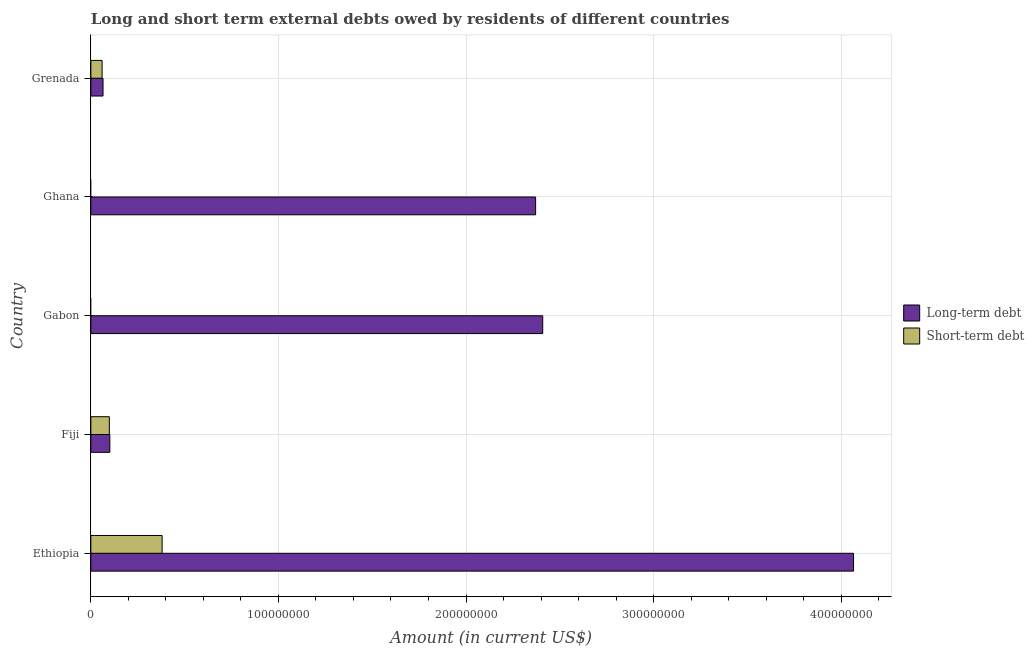How many bars are there on the 2nd tick from the top?
Your answer should be very brief. 1. How many bars are there on the 4th tick from the bottom?
Make the answer very short. 1. What is the label of the 4th group of bars from the top?
Provide a succinct answer. Fiji. In how many cases, is the number of bars for a given country not equal to the number of legend labels?
Your answer should be compact. 2. What is the long-term debts owed by residents in Grenada?
Make the answer very short. 6.49e+06. Across all countries, what is the maximum short-term debts owed by residents?
Make the answer very short. 3.80e+07. In which country was the long-term debts owed by residents maximum?
Your answer should be compact. Ethiopia. What is the total short-term debts owed by residents in the graph?
Your answer should be very brief. 5.39e+07. What is the difference between the long-term debts owed by residents in Fiji and that in Grenada?
Provide a succinct answer. 3.63e+06. What is the difference between the short-term debts owed by residents in Grenada and the long-term debts owed by residents in Ghana?
Provide a short and direct response. -2.31e+08. What is the average long-term debts owed by residents per country?
Make the answer very short. 1.80e+08. What is the difference between the short-term debts owed by residents and long-term debts owed by residents in Fiji?
Offer a terse response. -2.59e+05. What is the ratio of the long-term debts owed by residents in Fiji to that in Gabon?
Make the answer very short. 0.04. Is the long-term debts owed by residents in Ethiopia less than that in Ghana?
Give a very brief answer. No. Is the difference between the long-term debts owed by residents in Ethiopia and Grenada greater than the difference between the short-term debts owed by residents in Ethiopia and Grenada?
Provide a succinct answer. Yes. What is the difference between the highest and the second highest long-term debts owed by residents?
Your response must be concise. 1.66e+08. What is the difference between the highest and the lowest short-term debts owed by residents?
Offer a terse response. 3.80e+07. Is the sum of the short-term debts owed by residents in Ethiopia and Grenada greater than the maximum long-term debts owed by residents across all countries?
Keep it short and to the point. No. How many bars are there?
Give a very brief answer. 8. How many countries are there in the graph?
Your answer should be very brief. 5. Are the values on the major ticks of X-axis written in scientific E-notation?
Give a very brief answer. No. Does the graph contain grids?
Offer a terse response. Yes. Where does the legend appear in the graph?
Give a very brief answer. Center right. How are the legend labels stacked?
Keep it short and to the point. Vertical. What is the title of the graph?
Give a very brief answer. Long and short term external debts owed by residents of different countries. What is the label or title of the X-axis?
Offer a very short reply. Amount (in current US$). What is the label or title of the Y-axis?
Provide a short and direct response. Country. What is the Amount (in current US$) of Long-term debt in Ethiopia?
Your response must be concise. 4.07e+08. What is the Amount (in current US$) of Short-term debt in Ethiopia?
Give a very brief answer. 3.80e+07. What is the Amount (in current US$) of Long-term debt in Fiji?
Offer a terse response. 1.01e+07. What is the Amount (in current US$) of Short-term debt in Fiji?
Make the answer very short. 9.86e+06. What is the Amount (in current US$) of Long-term debt in Gabon?
Make the answer very short. 2.41e+08. What is the Amount (in current US$) of Short-term debt in Gabon?
Your answer should be compact. 0. What is the Amount (in current US$) in Long-term debt in Ghana?
Your response must be concise. 2.37e+08. What is the Amount (in current US$) of Long-term debt in Grenada?
Give a very brief answer. 6.49e+06. What is the Amount (in current US$) in Short-term debt in Grenada?
Offer a very short reply. 6.00e+06. Across all countries, what is the maximum Amount (in current US$) in Long-term debt?
Your answer should be compact. 4.07e+08. Across all countries, what is the maximum Amount (in current US$) in Short-term debt?
Provide a succinct answer. 3.80e+07. Across all countries, what is the minimum Amount (in current US$) of Long-term debt?
Your answer should be very brief. 6.49e+06. Across all countries, what is the minimum Amount (in current US$) in Short-term debt?
Your answer should be compact. 0. What is the total Amount (in current US$) in Long-term debt in the graph?
Your answer should be very brief. 9.01e+08. What is the total Amount (in current US$) of Short-term debt in the graph?
Offer a terse response. 5.39e+07. What is the difference between the Amount (in current US$) in Long-term debt in Ethiopia and that in Fiji?
Provide a succinct answer. 3.96e+08. What is the difference between the Amount (in current US$) in Short-term debt in Ethiopia and that in Fiji?
Give a very brief answer. 2.81e+07. What is the difference between the Amount (in current US$) of Long-term debt in Ethiopia and that in Gabon?
Your answer should be compact. 1.66e+08. What is the difference between the Amount (in current US$) in Long-term debt in Ethiopia and that in Ghana?
Give a very brief answer. 1.69e+08. What is the difference between the Amount (in current US$) of Long-term debt in Ethiopia and that in Grenada?
Ensure brevity in your answer.  4.00e+08. What is the difference between the Amount (in current US$) of Short-term debt in Ethiopia and that in Grenada?
Your answer should be compact. 3.20e+07. What is the difference between the Amount (in current US$) in Long-term debt in Fiji and that in Gabon?
Offer a terse response. -2.31e+08. What is the difference between the Amount (in current US$) of Long-term debt in Fiji and that in Ghana?
Offer a very short reply. -2.27e+08. What is the difference between the Amount (in current US$) of Long-term debt in Fiji and that in Grenada?
Keep it short and to the point. 3.63e+06. What is the difference between the Amount (in current US$) in Short-term debt in Fiji and that in Grenada?
Ensure brevity in your answer.  3.86e+06. What is the difference between the Amount (in current US$) in Long-term debt in Gabon and that in Ghana?
Your answer should be compact. 3.78e+06. What is the difference between the Amount (in current US$) of Long-term debt in Gabon and that in Grenada?
Provide a short and direct response. 2.34e+08. What is the difference between the Amount (in current US$) of Long-term debt in Ghana and that in Grenada?
Provide a short and direct response. 2.31e+08. What is the difference between the Amount (in current US$) of Long-term debt in Ethiopia and the Amount (in current US$) of Short-term debt in Fiji?
Provide a short and direct response. 3.97e+08. What is the difference between the Amount (in current US$) of Long-term debt in Ethiopia and the Amount (in current US$) of Short-term debt in Grenada?
Offer a terse response. 4.01e+08. What is the difference between the Amount (in current US$) of Long-term debt in Fiji and the Amount (in current US$) of Short-term debt in Grenada?
Your response must be concise. 4.12e+06. What is the difference between the Amount (in current US$) of Long-term debt in Gabon and the Amount (in current US$) of Short-term debt in Grenada?
Offer a very short reply. 2.35e+08. What is the difference between the Amount (in current US$) in Long-term debt in Ghana and the Amount (in current US$) in Short-term debt in Grenada?
Ensure brevity in your answer.  2.31e+08. What is the average Amount (in current US$) in Long-term debt per country?
Offer a very short reply. 1.80e+08. What is the average Amount (in current US$) in Short-term debt per country?
Offer a terse response. 1.08e+07. What is the difference between the Amount (in current US$) in Long-term debt and Amount (in current US$) in Short-term debt in Ethiopia?
Make the answer very short. 3.69e+08. What is the difference between the Amount (in current US$) in Long-term debt and Amount (in current US$) in Short-term debt in Fiji?
Offer a very short reply. 2.59e+05. What is the difference between the Amount (in current US$) of Long-term debt and Amount (in current US$) of Short-term debt in Grenada?
Provide a succinct answer. 4.93e+05. What is the ratio of the Amount (in current US$) in Long-term debt in Ethiopia to that in Fiji?
Offer a terse response. 40.18. What is the ratio of the Amount (in current US$) of Short-term debt in Ethiopia to that in Fiji?
Ensure brevity in your answer.  3.85. What is the ratio of the Amount (in current US$) in Long-term debt in Ethiopia to that in Gabon?
Ensure brevity in your answer.  1.69. What is the ratio of the Amount (in current US$) in Long-term debt in Ethiopia to that in Ghana?
Offer a very short reply. 1.71. What is the ratio of the Amount (in current US$) in Long-term debt in Ethiopia to that in Grenada?
Offer a very short reply. 62.62. What is the ratio of the Amount (in current US$) in Short-term debt in Ethiopia to that in Grenada?
Your answer should be compact. 6.33. What is the ratio of the Amount (in current US$) in Long-term debt in Fiji to that in Gabon?
Give a very brief answer. 0.04. What is the ratio of the Amount (in current US$) of Long-term debt in Fiji to that in Ghana?
Make the answer very short. 0.04. What is the ratio of the Amount (in current US$) of Long-term debt in Fiji to that in Grenada?
Ensure brevity in your answer.  1.56. What is the ratio of the Amount (in current US$) of Short-term debt in Fiji to that in Grenada?
Keep it short and to the point. 1.64. What is the ratio of the Amount (in current US$) of Long-term debt in Gabon to that in Ghana?
Your response must be concise. 1.02. What is the ratio of the Amount (in current US$) in Long-term debt in Gabon to that in Grenada?
Provide a succinct answer. 37.1. What is the ratio of the Amount (in current US$) of Long-term debt in Ghana to that in Grenada?
Ensure brevity in your answer.  36.52. What is the difference between the highest and the second highest Amount (in current US$) of Long-term debt?
Provide a short and direct response. 1.66e+08. What is the difference between the highest and the second highest Amount (in current US$) of Short-term debt?
Make the answer very short. 2.81e+07. What is the difference between the highest and the lowest Amount (in current US$) of Long-term debt?
Your answer should be compact. 4.00e+08. What is the difference between the highest and the lowest Amount (in current US$) in Short-term debt?
Make the answer very short. 3.80e+07. 